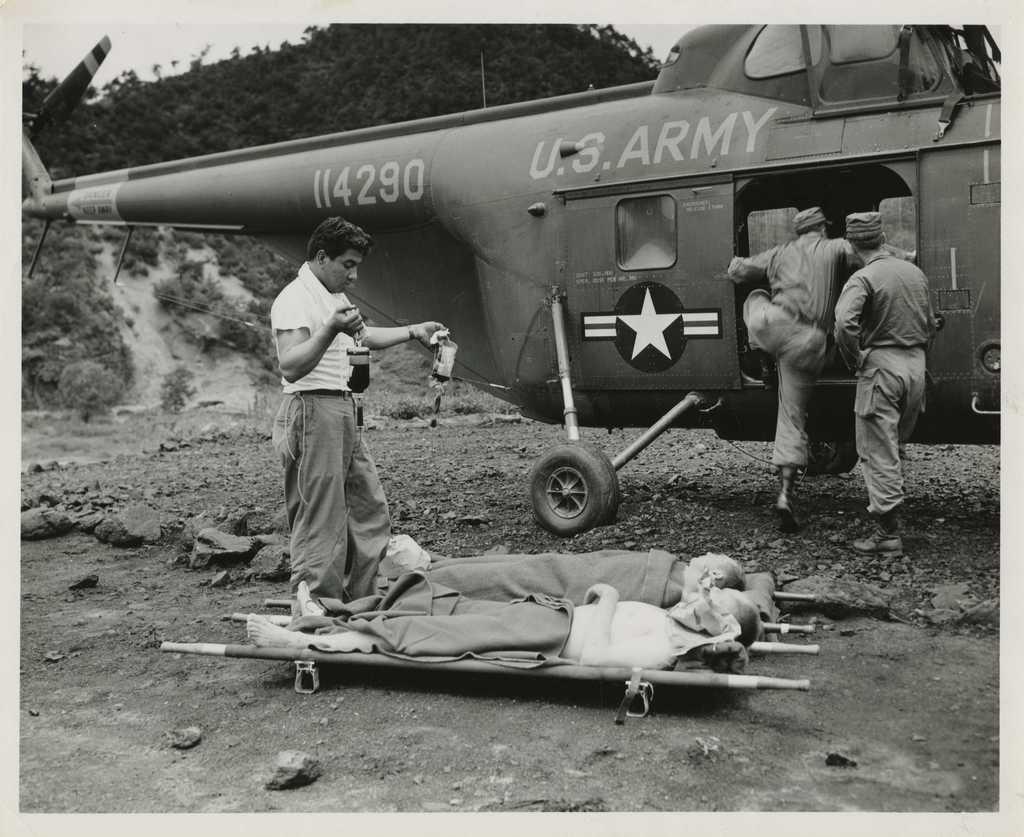Which country owns this helicopter?
Provide a short and direct response. U.s. What is the serial number of the helicopter?
Your response must be concise. 114290. 